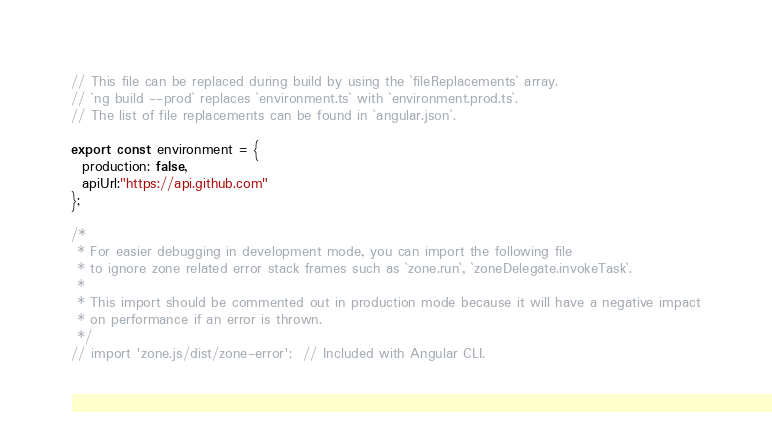Convert code to text. <code><loc_0><loc_0><loc_500><loc_500><_TypeScript_>// This file can be replaced during build by using the `fileReplacements` array.
// `ng build --prod` replaces `environment.ts` with `environment.prod.ts`.
// The list of file replacements can be found in `angular.json`.

export const environment = {
  production: false,
  apiUrl:"https://api.github.com"
};

/*
 * For easier debugging in development mode, you can import the following file
 * to ignore zone related error stack frames such as `zone.run`, `zoneDelegate.invokeTask`.
 *
 * This import should be commented out in production mode because it will have a negative impact
 * on performance if an error is thrown.
 */
// import 'zone.js/dist/zone-error';  // Included with Angular CLI.
</code> 